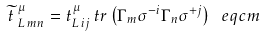<formula> <loc_0><loc_0><loc_500><loc_500>\widetilde { t } \, ^ { \mu } _ { L \, m n } = t ^ { \mu } _ { L \, i j } \, t r \left ( \Gamma _ { m } \sigma ^ { - i } \Gamma _ { n } \sigma ^ { + j } \right ) \ e q c m</formula> 